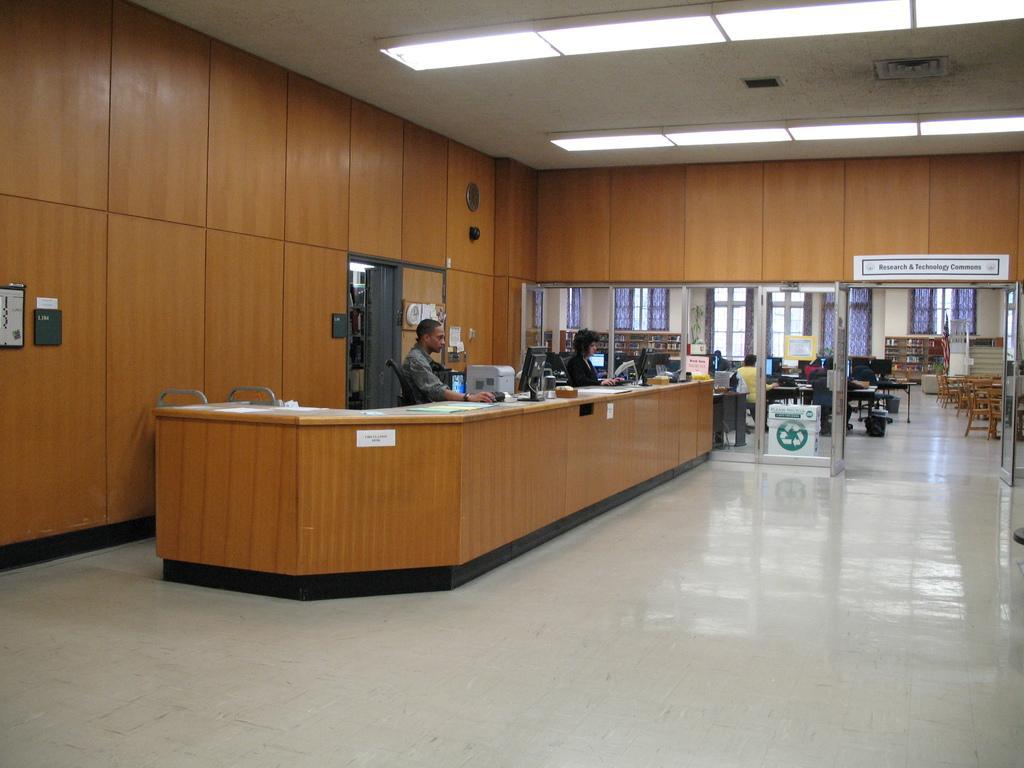Describe this image in one or two sentences. Here we can see a two persons sitting on a chair and working on a computer. This is a glass door which is used to enter into this room where a table and chairs are available. 